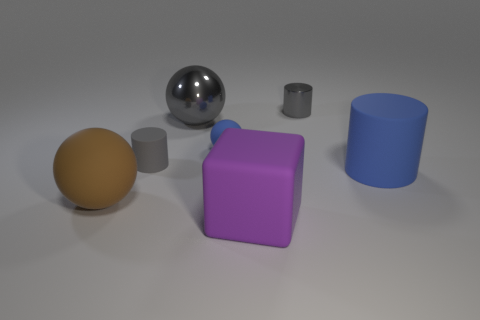Is the color of the small matte sphere the same as the large cylinder?
Make the answer very short. Yes. There is a large metallic thing that is the same shape as the small blue thing; what is its color?
Offer a very short reply. Gray. Is the material of the cube the same as the small object behind the tiny blue matte thing?
Provide a short and direct response. No. There is a object that is in front of the large sphere in front of the gray matte thing; what is its shape?
Offer a very short reply. Cube. Is the size of the blue rubber thing that is to the right of the blue rubber sphere the same as the large brown rubber sphere?
Offer a terse response. Yes. What number of other objects are the same shape as the small blue rubber thing?
Provide a short and direct response. 2. There is a matte ball that is behind the blue matte cylinder; is it the same color as the big cylinder?
Ensure brevity in your answer.  Yes. Are there any other big cylinders that have the same color as the big matte cylinder?
Your response must be concise. No. How many purple cubes are on the left side of the small rubber cylinder?
Give a very brief answer. 0. How many other things are the same size as the gray rubber cylinder?
Make the answer very short. 2. 